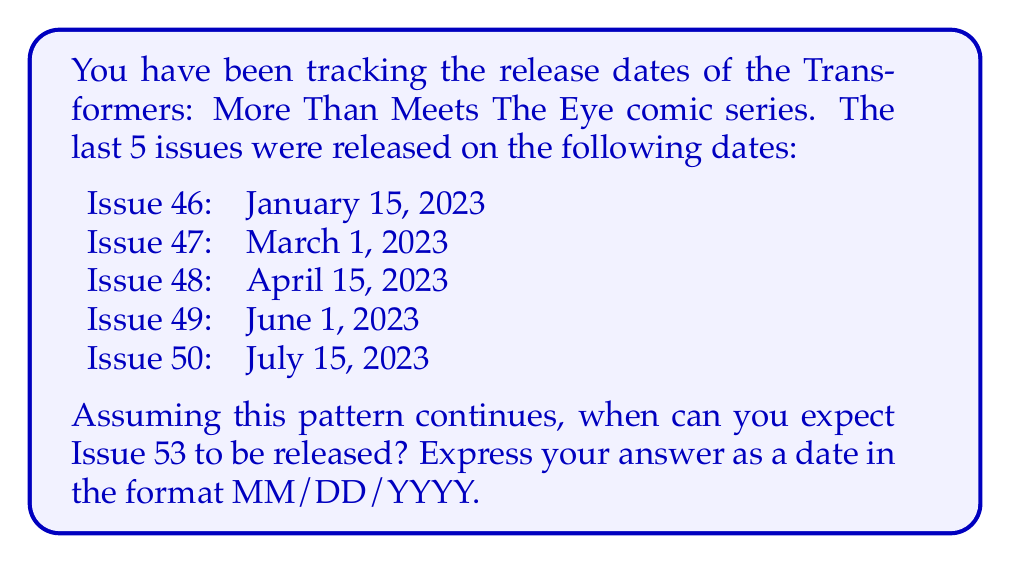Could you help me with this problem? To solve this problem, we need to analyze the time series data and identify the pattern in the release dates. Let's follow these steps:

1. Calculate the time intervals between consecutive issues:
   Issue 46 to 47: 45 days
   Issue 47 to 48: 45 days
   Issue 48 to 49: 47 days
   Issue 49 to 50: 44 days

2. We can see that the interval is approximately 45 days between issues. Let's use this as our forecast interval.

3. To predict Issue 53, we need to add three 45-day intervals to the release date of Issue 50:

   $$ \text{Issue 53 date} = \text{Issue 50 date} + (3 \times 45 \text{ days}) $$

4. Starting from July 15, 2023, we add 135 days (3 × 45):
   
   $$ \text{July 15, 2023} + 135 \text{ days} $$

5. To calculate this, we can use a simple date calculation:
   - July has 31 days, so we use the remaining 16 days
   - August has 31 days
   - September has 30 days
   - October has 31 days
   - November has 27 days left to reach 135 days total

6. Counting these days brings us to November 27, 2023.

Therefore, based on the historical release pattern, we can expect Issue 53 to be released on November 27, 2023.
Answer: 11/27/2023 